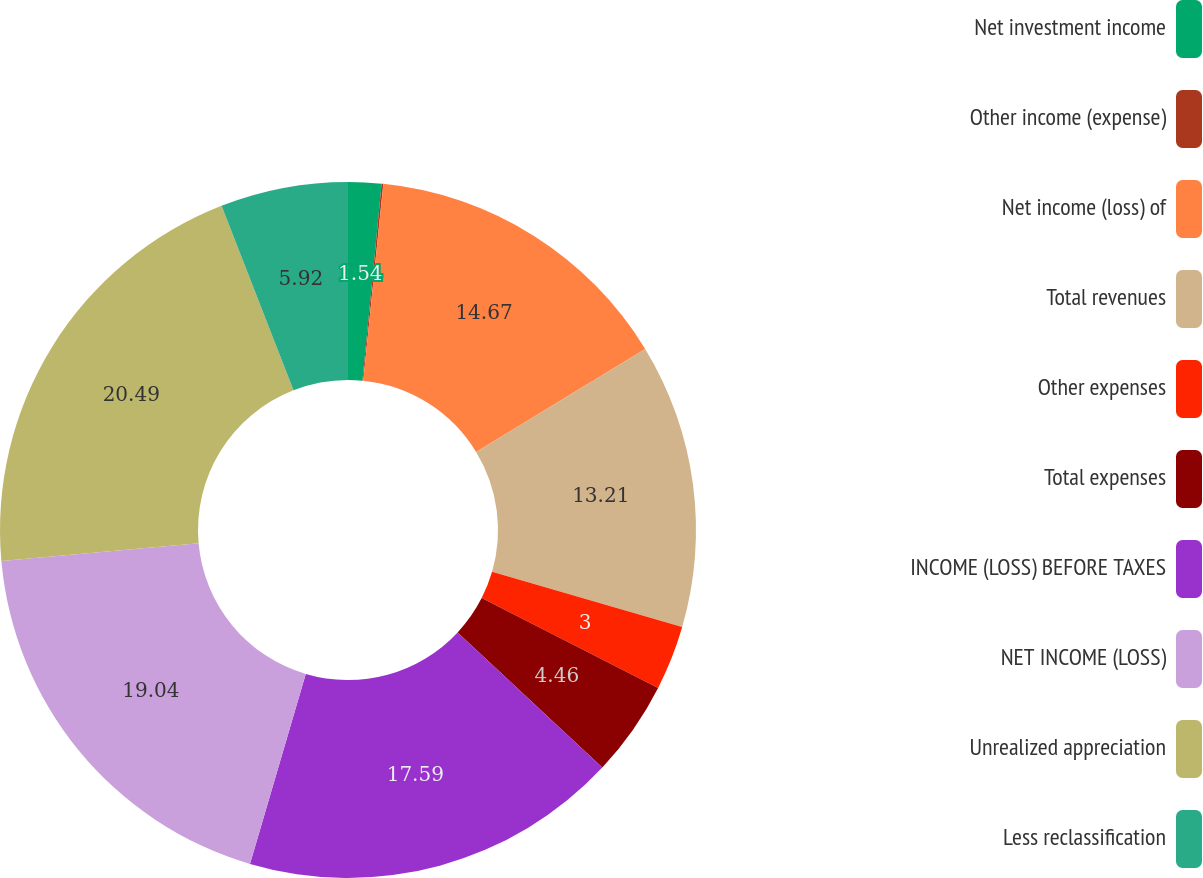Convert chart. <chart><loc_0><loc_0><loc_500><loc_500><pie_chart><fcel>Net investment income<fcel>Other income (expense)<fcel>Net income (loss) of<fcel>Total revenues<fcel>Other expenses<fcel>Total expenses<fcel>INCOME (LOSS) BEFORE TAXES<fcel>NET INCOME (LOSS)<fcel>Unrealized appreciation<fcel>Less reclassification<nl><fcel>1.54%<fcel>0.08%<fcel>14.67%<fcel>13.21%<fcel>3.0%<fcel>4.46%<fcel>17.59%<fcel>19.04%<fcel>20.5%<fcel>5.92%<nl></chart> 